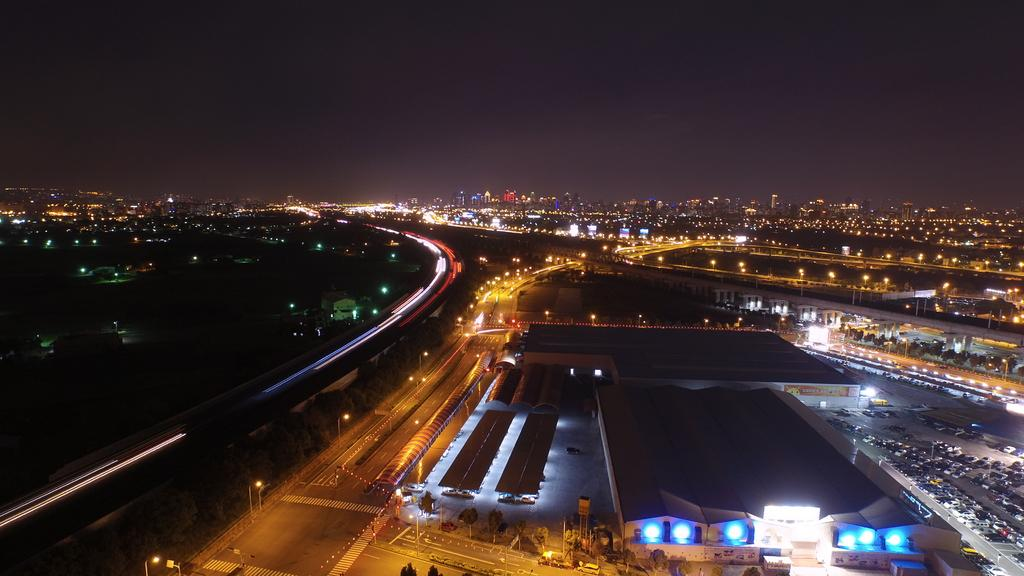What type of view is shown in the image? The image is a top view of a city. What are some features of the city that can be seen in the image? There are roads, buildings, lampposts, vehicles, and trees in the image. Can you see anyone kicking a fire in the image? There is no fire or anyone kicking in the image. Is there a tub visible in the image? There is no tub present in the image. 